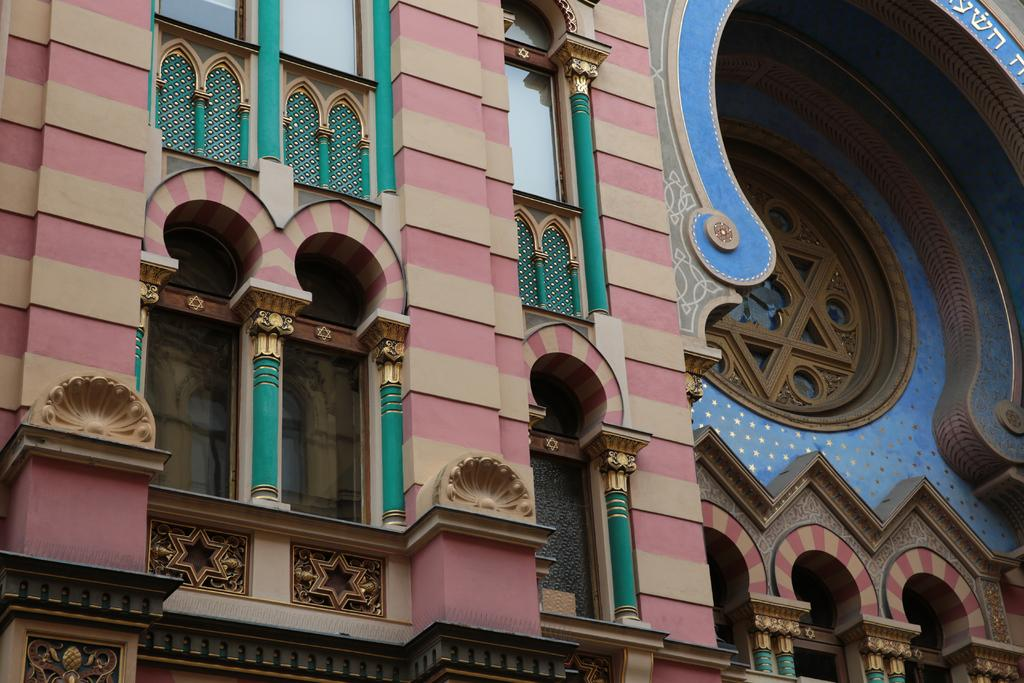What type of structure is present in the image? There is a building in the image. What feature can be observed on the building? The building has glass windows. Where is the mailbox located in the image? There is no mailbox present in the image. What type of bait is used to catch fish in the image? There is no fishing or bait present in the image. 